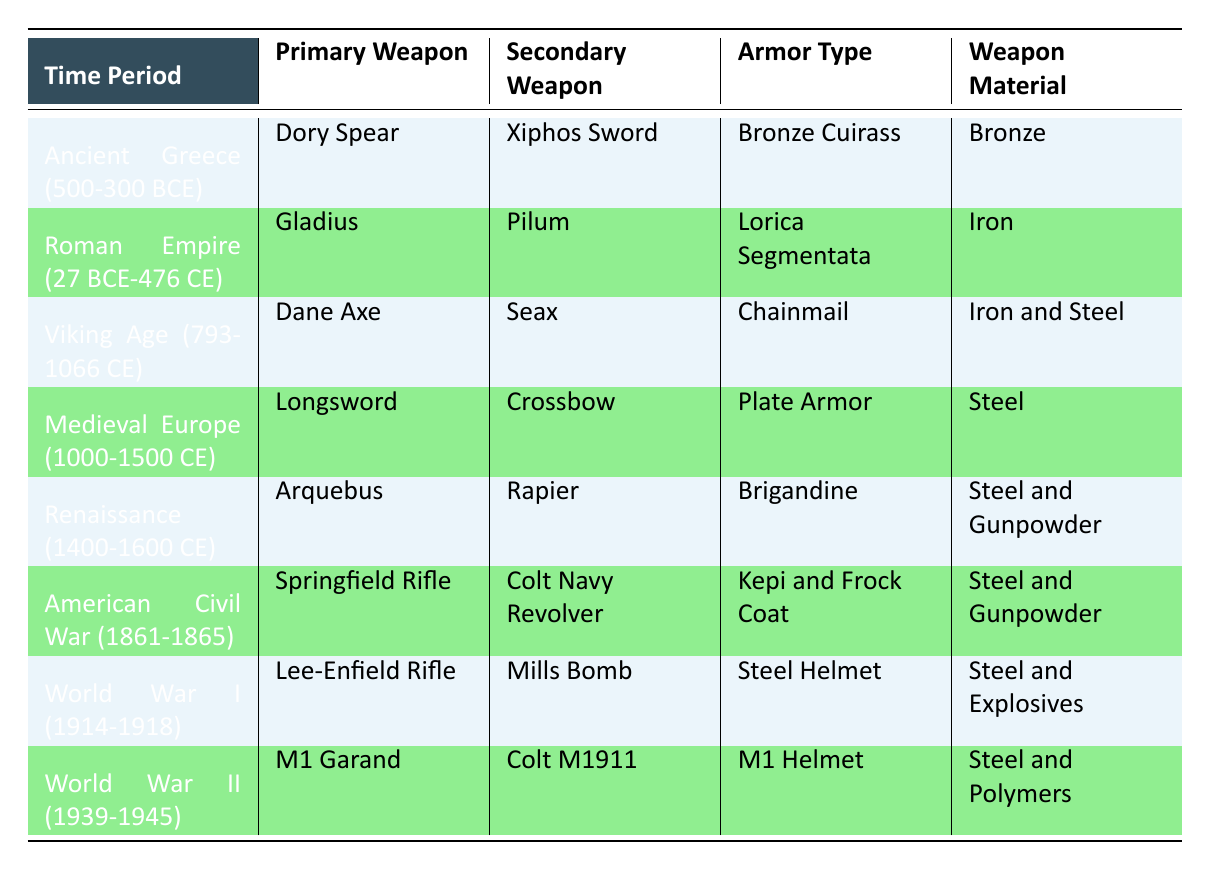What was the primary weapon used in Medieval Europe? The table shows that the primary weapon for the Medieval Europe period (1000-1500 CE) is the Longsword.
Answer: Longsword Which time period utilized the Dory Spear as a primary weapon? According to the table, the Ancient Greece period (500-300 BCE) utilized the Dory Spear as its primary weapon.
Answer: Ancient Greece (500-300 BCE) Did the Viking Age use steel in their weapons? The table indicates that during the Viking Age (793-1066 CE), the Dane Axe and Seax were made of Iron and Steel, confirming the use of steel in their weapons.
Answer: Yes What is the average number of weapon materials used across the different time periods? By counting the unique materials listed for each period, we find 5 unique material types: Bronze, Iron, Steel, Steel and Gunpowder, Steel and Polymers. Therefore, the average number of unique materials used is 5/8 = 0.625. Since it's not conventional to average categories, we can summarize it simply: 5 material types
Answer: 5 material types In which time period were firearms first introduced as primary weapons? The table indicates that firearms, specifically the Arquebus, were first introduced during the Renaissance period (1400-1600 CE) as a primary weapon.
Answer: Renaissance (1400-1600 CE) How many time periods featured the use of steel in armor? The table shows that steel was used in armor during the Medieval Europe (Plate Armor), Renaissance (Brigandine), American Civil War (Kepi and Frock Coat), World War I (Steel Helmet), and World War II (M1 Helmet), totaling 5 time periods.
Answer: 5 time periods Is it true that the Roman Empire used a sword as its primary weapon? The primary weapon for the Roman Empire (27 BCE-476 CE) was indeed the Gladius, which is a type of sword. This confirms the statement as true.
Answer: Yes Which time period had both a rifle and a revolver as weapons? The American Civil War (1861-1865) had the Springfield Rifle as the primary weapon and the Colt Navy Revolver as the secondary weapon, making it the time period that included both.
Answer: American Civil War (1861-1865) 